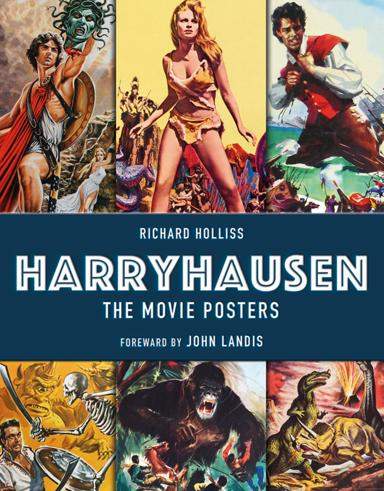What genres of films do the movie posters in the book predominantly represent? The movie posters in the book predominantly represent genres of fantasy, adventure, and science fiction. These posters reflect the thematic styles of Ray Harryhausen's films, known for their imaginative creatures and epic storytelling. Can you name a few films by Harryhausen that are likely included in this book? Likely some of the films included in the book are 'Jason and the Argonauts', 'Clash of the Titans', and 'The 7th Voyage of Sinbad'. These films are celebrated for their iconic use of stop-motion effects in creating engaging and dynamic scenes. 